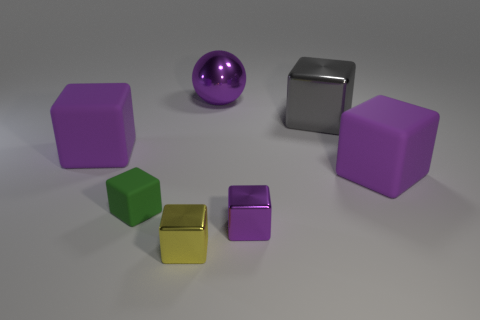Add 3 large blue rubber things. How many objects exist? 10 Subtract 6 cubes. How many cubes are left? 0 Subtract all green blocks. Subtract all cyan cylinders. How many blocks are left? 5 Subtract all purple spheres. How many yellow cubes are left? 1 Subtract all green blocks. Subtract all big blue cubes. How many objects are left? 6 Add 4 big spheres. How many big spheres are left? 5 Add 1 green matte blocks. How many green matte blocks exist? 2 Subtract all purple blocks. How many blocks are left? 3 Subtract all small green cubes. How many cubes are left? 5 Subtract 0 yellow cylinders. How many objects are left? 7 